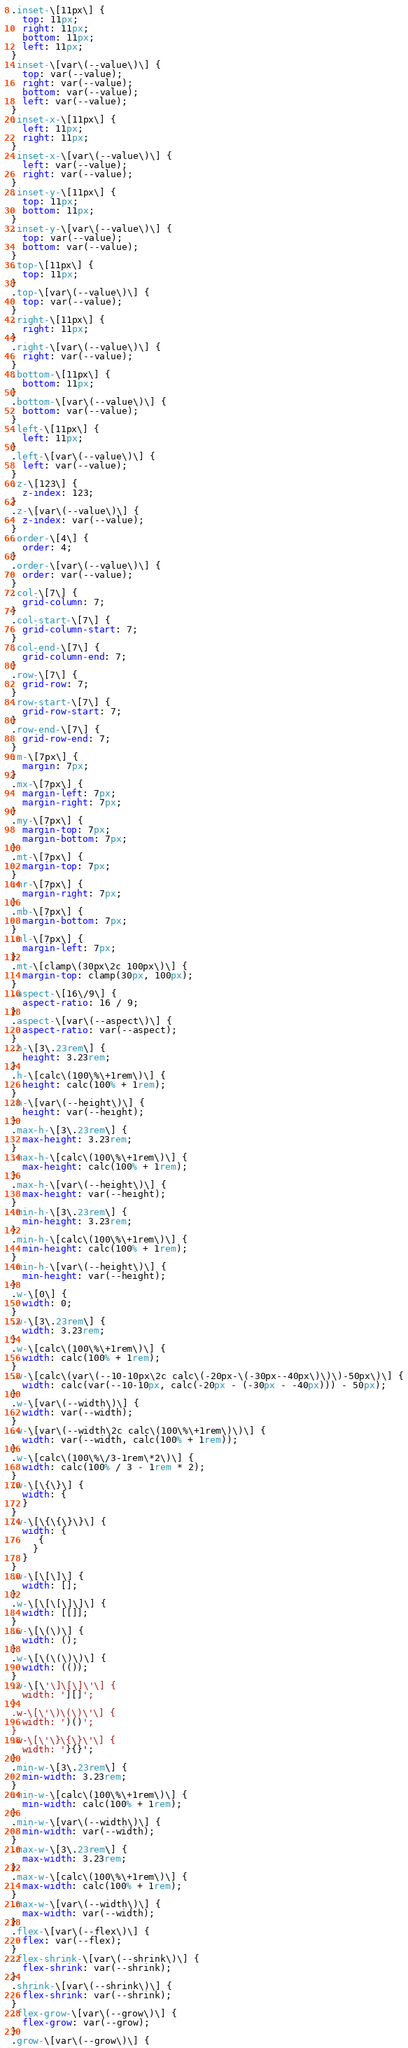<code> <loc_0><loc_0><loc_500><loc_500><_CSS_>.inset-\[11px\] {
  top: 11px;
  right: 11px;
  bottom: 11px;
  left: 11px;
}
.inset-\[var\(--value\)\] {
  top: var(--value);
  right: var(--value);
  bottom: var(--value);
  left: var(--value);
}
.inset-x-\[11px\] {
  left: 11px;
  right: 11px;
}
.inset-x-\[var\(--value\)\] {
  left: var(--value);
  right: var(--value);
}
.inset-y-\[11px\] {
  top: 11px;
  bottom: 11px;
}
.inset-y-\[var\(--value\)\] {
  top: var(--value);
  bottom: var(--value);
}
.top-\[11px\] {
  top: 11px;
}
.top-\[var\(--value\)\] {
  top: var(--value);
}
.right-\[11px\] {
  right: 11px;
}
.right-\[var\(--value\)\] {
  right: var(--value);
}
.bottom-\[11px\] {
  bottom: 11px;
}
.bottom-\[var\(--value\)\] {
  bottom: var(--value);
}
.left-\[11px\] {
  left: 11px;
}
.left-\[var\(--value\)\] {
  left: var(--value);
}
.z-\[123\] {
  z-index: 123;
}
.z-\[var\(--value\)\] {
  z-index: var(--value);
}
.order-\[4\] {
  order: 4;
}
.order-\[var\(--value\)\] {
  order: var(--value);
}
.col-\[7\] {
  grid-column: 7;
}
.col-start-\[7\] {
  grid-column-start: 7;
}
.col-end-\[7\] {
  grid-column-end: 7;
}
.row-\[7\] {
  grid-row: 7;
}
.row-start-\[7\] {
  grid-row-start: 7;
}
.row-end-\[7\] {
  grid-row-end: 7;
}
.m-\[7px\] {
  margin: 7px;
}
.mx-\[7px\] {
  margin-left: 7px;
  margin-right: 7px;
}
.my-\[7px\] {
  margin-top: 7px;
  margin-bottom: 7px;
}
.mt-\[7px\] {
  margin-top: 7px;
}
.mr-\[7px\] {
  margin-right: 7px;
}
.mb-\[7px\] {
  margin-bottom: 7px;
}
.ml-\[7px\] {
  margin-left: 7px;
}
.mt-\[clamp\(30px\2c 100px\)\] {
  margin-top: clamp(30px, 100px);
}
.aspect-\[16\/9\] {
  aspect-ratio: 16 / 9;
}
.aspect-\[var\(--aspect\)\] {
  aspect-ratio: var(--aspect);
}
.h-\[3\.23rem\] {
  height: 3.23rem;
}
.h-\[calc\(100\%\+1rem\)\] {
  height: calc(100% + 1rem);
}
.h-\[var\(--height\)\] {
  height: var(--height);
}
.max-h-\[3\.23rem\] {
  max-height: 3.23rem;
}
.max-h-\[calc\(100\%\+1rem\)\] {
  max-height: calc(100% + 1rem);
}
.max-h-\[var\(--height\)\] {
  max-height: var(--height);
}
.min-h-\[3\.23rem\] {
  min-height: 3.23rem;
}
.min-h-\[calc\(100\%\+1rem\)\] {
  min-height: calc(100% + 1rem);
}
.min-h-\[var\(--height\)\] {
  min-height: var(--height);
}
.w-\[0\] {
  width: 0;
}
.w-\[3\.23rem\] {
  width: 3.23rem;
}
.w-\[calc\(100\%\+1rem\)\] {
  width: calc(100% + 1rem);
}
.w-\[calc\(var\(--10-10px\2c calc\(-20px-\(-30px--40px\)\)\)-50px\)\] {
  width: calc(var(--10-10px, calc(-20px - (-30px - -40px))) - 50px);
}
.w-\[var\(--width\)\] {
  width: var(--width);
}
.w-\[var\(--width\2c calc\(100\%\+1rem\)\)\] {
  width: var(--width, calc(100% + 1rem));
}
.w-\[calc\(100\%\/3-1rem\*2\)\] {
  width: calc(100% / 3 - 1rem * 2);
}
.w-\[\{\}\] {
  width: {
  }
}
.w-\[\{\{\}\}\] {
  width: {
     {
    }
  }
}
.w-\[\[\]\] {
  width: [];
}
.w-\[\[\[\]\]\] {
  width: [[]];
}
.w-\[\(\)\] {
  width: ();
}
.w-\[\(\(\)\)\] {
  width: (());
}
.w-\[\'\]\[\]\'\] {
  width: '][]';
}
.w-\[\'\)\(\)\'\] {
  width: ')()';
}
.w-\[\'\}\{\}\'\] {
  width: '}{}';
}
.min-w-\[3\.23rem\] {
  min-width: 3.23rem;
}
.min-w-\[calc\(100\%\+1rem\)\] {
  min-width: calc(100% + 1rem);
}
.min-w-\[var\(--width\)\] {
  min-width: var(--width);
}
.max-w-\[3\.23rem\] {
  max-width: 3.23rem;
}
.max-w-\[calc\(100\%\+1rem\)\] {
  max-width: calc(100% + 1rem);
}
.max-w-\[var\(--width\)\] {
  max-width: var(--width);
}
.flex-\[var\(--flex\)\] {
  flex: var(--flex);
}
.flex-shrink-\[var\(--shrink\)\] {
  flex-shrink: var(--shrink);
}
.shrink-\[var\(--shrink\)\] {
  flex-shrink: var(--shrink);
}
.flex-grow-\[var\(--grow\)\] {
  flex-grow: var(--grow);
}
.grow-\[var\(--grow\)\] {</code> 